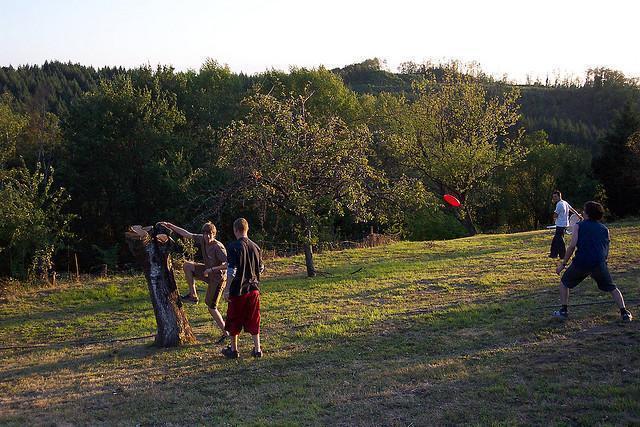Why does the boy have his leg on the tree?
Indicate the correct response and explain using: 'Answer: answer
Rationale: rationale.'
Options: To wipe, to kick, to itch, to climb. Answer: to climb.
Rationale: He wants to get up on the stump. 